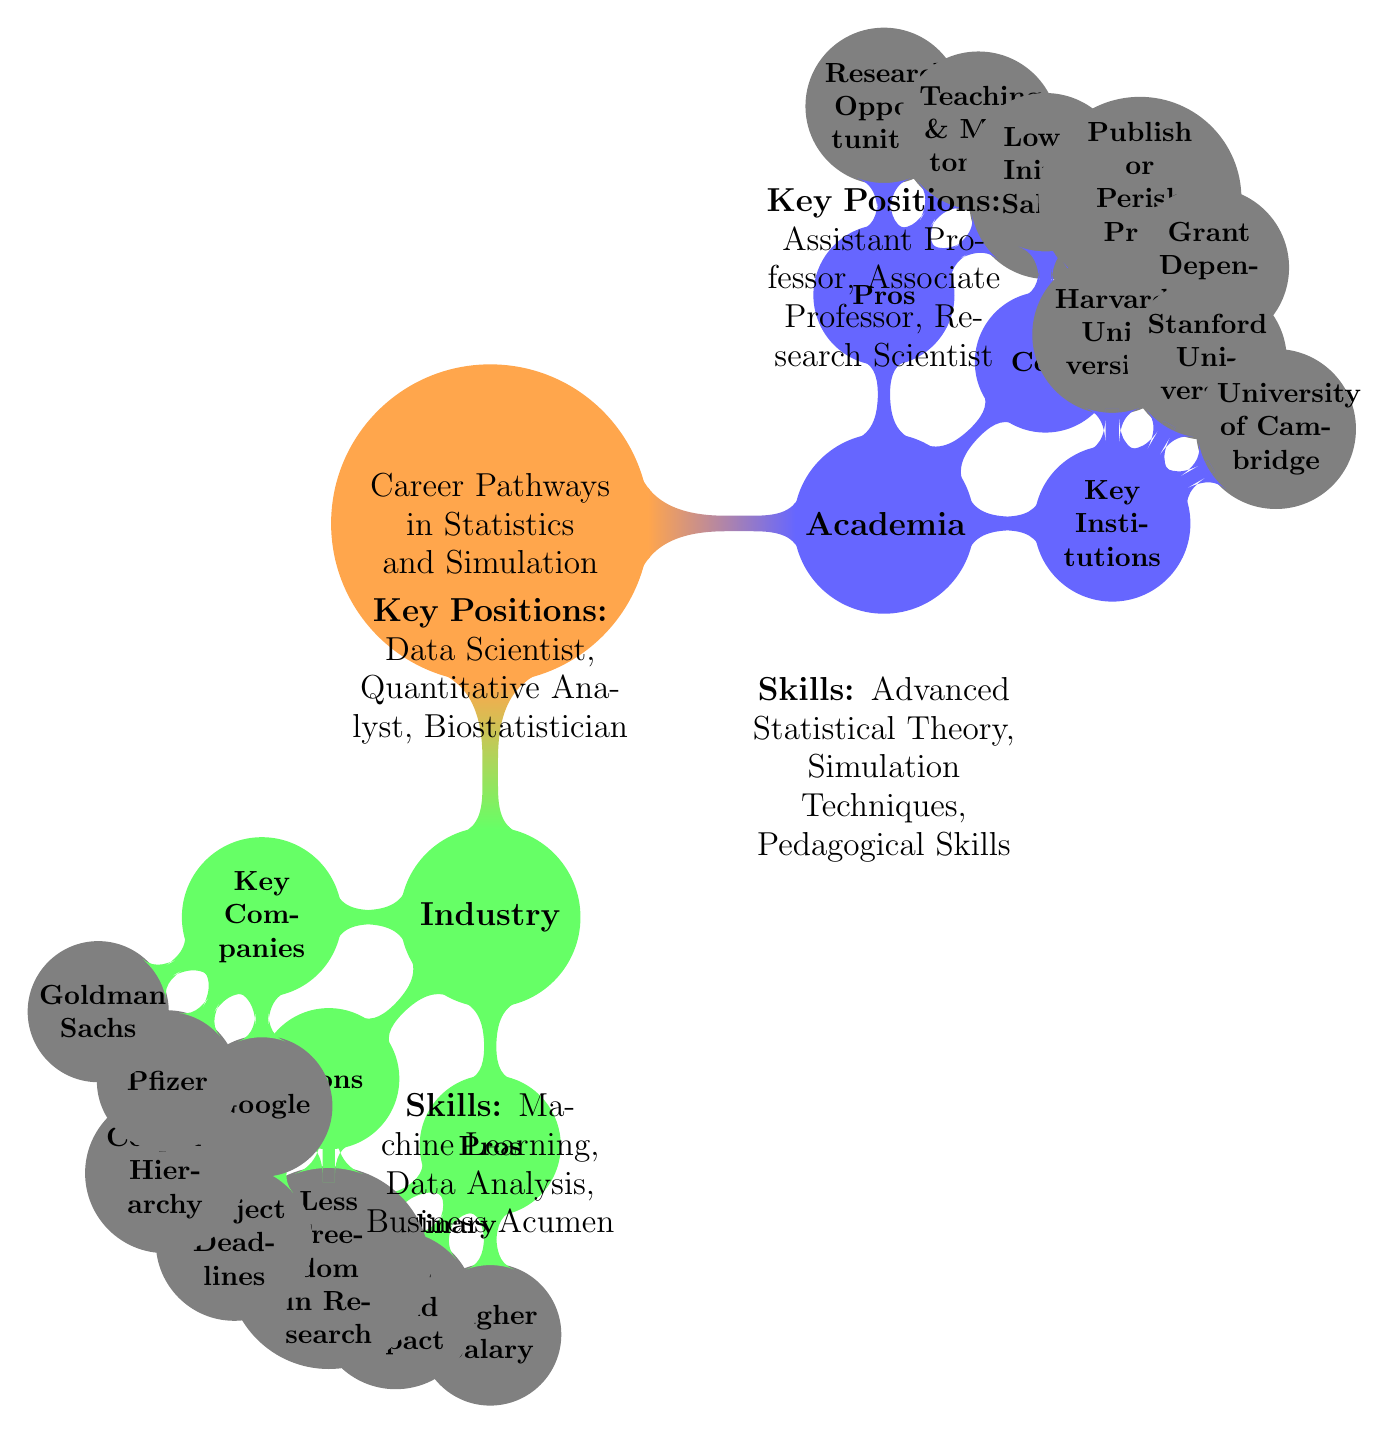What are the pros of academia in statistics? The diagram lists three pros of academia: "Research Opportunities," "Teaching & Mentorship," and "Academic Freedom." This information can be found directly under the "Pros" node of the "Academia" section.
Answer: Research Opportunities, Teaching & Mentorship, Academic Freedom How many key positions are listed for industry? The diagram specifies three key positions in the "Industry" section: "Data Scientist," "Quantitative Analyst," and "Biostatistician." This is derived from the corresponding node in the industry part of the mind map.
Answer: 3 What is one con associated with working in academia? Among the cons outlined in the "Academia" section, one example provided is "Lower Initial Salary." The answer comes from the list under the "Cons" node of academia.
Answer: Lower Initial Salary What is a skill required in academia? The diagram mentions several skills required in academia, including "Advanced Statistical Theory," "Simulation Techniques," and "Pedagogical Skills." Any of these can be considered a valid answer.
Answer: Advanced Statistical Theory Which companies are listed as key players in the industry? The diagram highlights three key companies in the "Industry" section: "Google," "Pfizer," and "Goldman Sachs." This information can be found under the "Key Companies" node of the industry part of the mind map.
Answer: Google, Pfizer, Goldman Sachs How does research freedom compare between academia and industry? In the diagram, "Academic Freedom" is a pro listed under academia, while "Less Freedom in Research" is a con in industry. This indicates that academia offers more freedom than industry regarding research conduct.
Answer: Academia offers more freedom What are the pros of industry in statistics? The diagram outlines three pros for the "Industry" section: "Higher Salary," "Real-World Impact," and "Interdisciplinary Teams." This information is listed under the "Pros" node of the industry part.
Answer: Higher Salary, Real-World Impact, Interdisciplinary Teams What type of positions are common in academia? In the diagram, the key positions listed for academia are "Assistant Professor," "Associate Professor," and "Research Scientist," which are detailed adjacent to the academia section.
Answer: Assistant Professor, Associate Professor, Research Scientist 